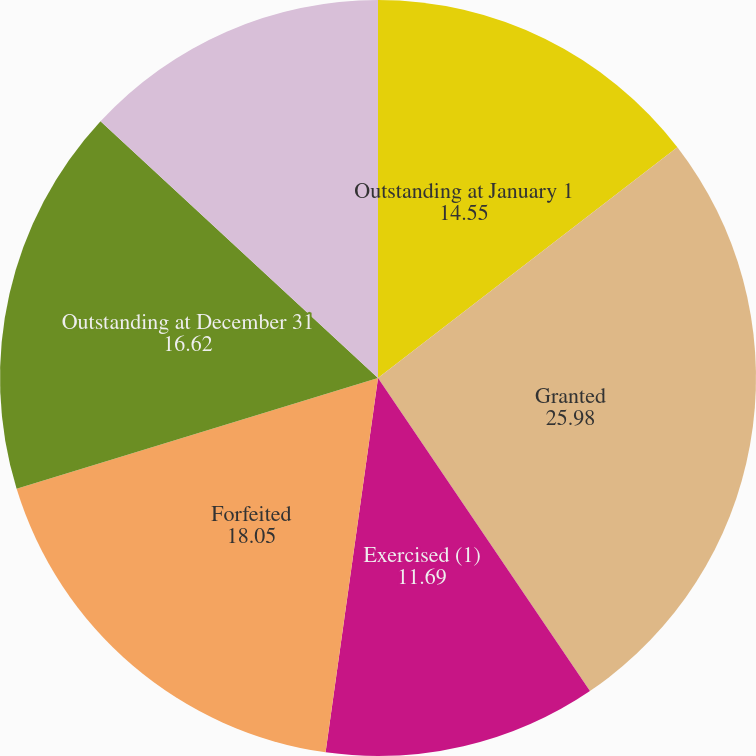Convert chart. <chart><loc_0><loc_0><loc_500><loc_500><pie_chart><fcel>Outstanding at January 1<fcel>Granted<fcel>Exercised (1)<fcel>Forfeited<fcel>Outstanding at December 31<fcel>Stock Options/SARs Exercisable<nl><fcel>14.55%<fcel>25.98%<fcel>11.69%<fcel>18.05%<fcel>16.62%<fcel>13.12%<nl></chart> 